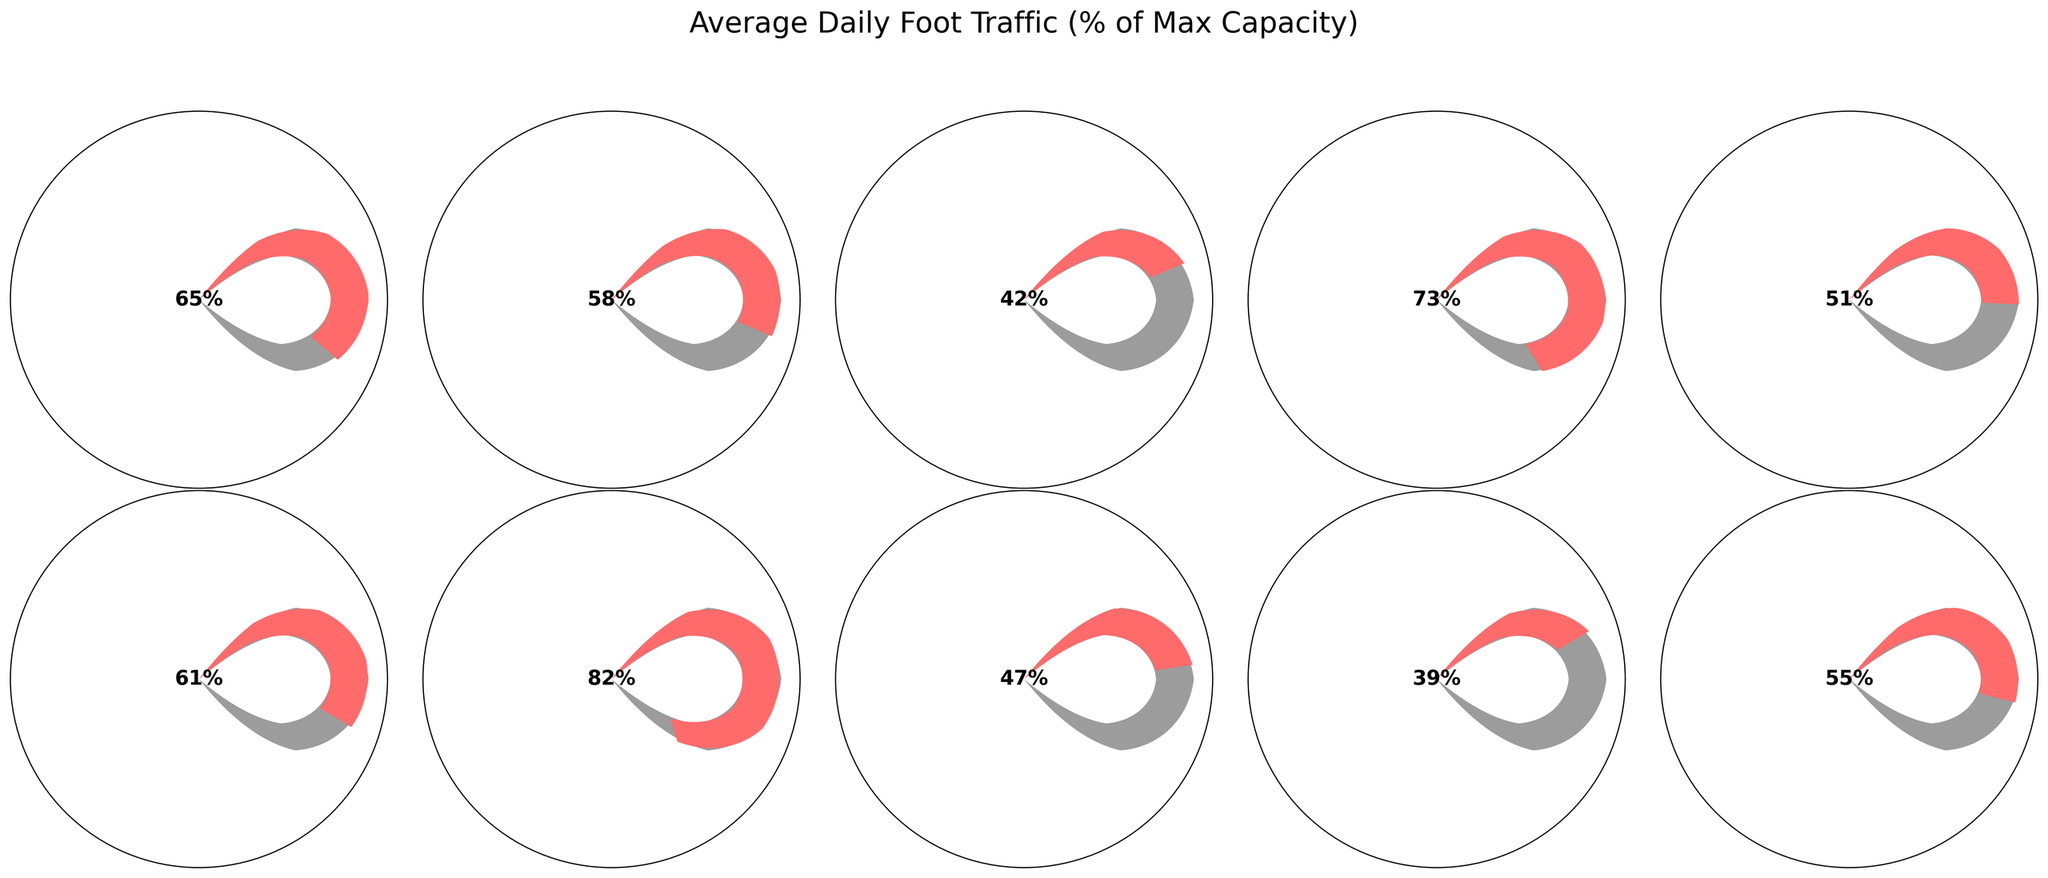what's the title of the gauge chart? The title of the gauge chart is usually displayed prominently at the top of the figure.
Answer: Average Daily Foot Traffic (% of Max Capacity) How many store locations are represented in the figure? Count the number of gauge plots in the figure. Each plot represents one store location.
Answer: 10 Which store has the highest average daily foot traffic? Among the gauge charts, find the one with the needle pointing to the highest percentage.
Answer: Sweetwater Which store has the lowest average daily foot traffic? Among the gauge charts, find the one with the needle pointing to the lowest percentage.
Answer: Reverb What is the average foot traffic across all stores? Add up the percentages of foot traffic for all stores and divide by the number of stores. (65 + 58 + 42 + 73 + 51 + 61 + 82 + 47 + 39 + 55) / 10 = 573 / 10 = 57.3%
Answer: 57.3% What is the difference in foot traffic between Drum World and Reverb? Find the foot traffic percentages for Drum World (73%) and Reverb (39%), then calculate the difference. 73 - 39 = 34%
Answer: 34% Which stores have foot traffic greater than 60%? Identify the gauges where the needle points to a percentage greater than 60%.
Answer: Guitar Center, Drum World, Long & McQuade, Sweetwater What is the sum of the foot traffic percentages for Music & Arts and Musician's Friend? Find the percentages for Music & Arts (51%) and Musician's Friend (47%), then add them together. 51 + 47 = 98%
Answer: 98% Is the foot traffic of West Music closer to 30% or 50%? Compare the foot traffic percentage of West Music (42%) to 30 and 50. The difference to 30 is 12, and the difference to 50 is 8. Therefore, it is closer to 50%.
Answer: 50% What is the median foot traffic percentage among the stores? Arrange the foot traffic percentages in ascending order and find the middle value. The percentages are 39, 42, 47, 51, 55, 58, 61, 65, 73, 82. The median value is the average of 55 and 58. (55 + 58) / 2 = 56.5%
Answer: 56.5% 